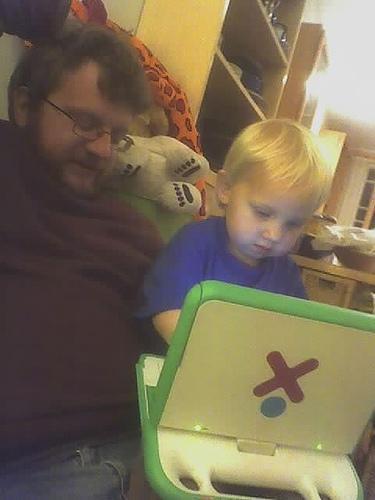What kind of action is the boy taking?
Indicate the correct choice and explain in the format: 'Answer: answer
Rationale: rationale.'
Options: Typing, throwing, running, kicking. Answer: typing.
Rationale: The action is typing. 